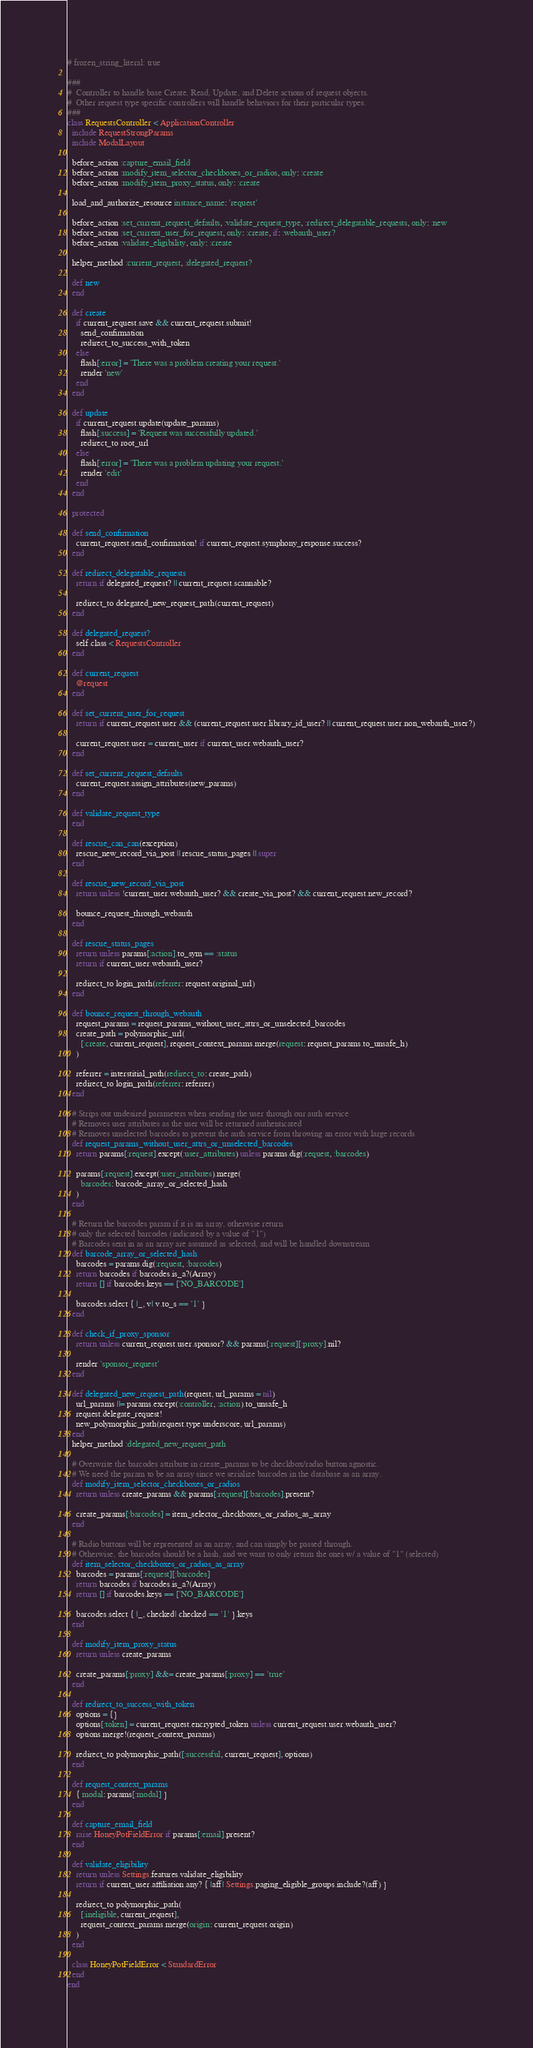<code> <loc_0><loc_0><loc_500><loc_500><_Ruby_># frozen_string_literal: true

###
#  Controller to handle base Create, Read, Update, and Delete actions of request objects.
#  Other request type specific controllers will handle behaviors for their particular types.
###
class RequestsController < ApplicationController
  include RequestStrongParams
  include ModalLayout

  before_action :capture_email_field
  before_action :modify_item_selector_checkboxes_or_radios, only: :create
  before_action :modify_item_proxy_status, only: :create

  load_and_authorize_resource instance_name: 'request'

  before_action :set_current_request_defaults, :validate_request_type, :redirect_delegatable_requests, only: :new
  before_action :set_current_user_for_request, only: :create, if: :webauth_user?
  before_action :validate_eligibility, only: :create

  helper_method :current_request, :delegated_request?

  def new
  end

  def create
    if current_request.save && current_request.submit!
      send_confirmation
      redirect_to_success_with_token
    else
      flash[:error] = 'There was a problem creating your request.'
      render 'new'
    end
  end

  def update
    if current_request.update(update_params)
      flash[:success] = 'Request was successfully updated.'
      redirect_to root_url
    else
      flash[:error] = 'There was a problem updating your request.'
      render 'edit'
    end
  end

  protected

  def send_confirmation
    current_request.send_confirmation! if current_request.symphony_response.success?
  end

  def redirect_delegatable_requests
    return if delegated_request? || current_request.scannable?

    redirect_to delegated_new_request_path(current_request)
  end

  def delegated_request?
    self.class < RequestsController
  end

  def current_request
    @request
  end

  def set_current_user_for_request
    return if current_request.user && (current_request.user.library_id_user? || current_request.user.non_webauth_user?)

    current_request.user = current_user if current_user.webauth_user?
  end

  def set_current_request_defaults
    current_request.assign_attributes(new_params)
  end

  def validate_request_type
  end

  def rescue_can_can(exception)
    rescue_new_record_via_post || rescue_status_pages || super
  end

  def rescue_new_record_via_post
    return unless !current_user.webauth_user? && create_via_post? && current_request.new_record?

    bounce_request_through_webauth
  end

  def rescue_status_pages
    return unless params[:action].to_sym == :status
    return if current_user.webauth_user?

    redirect_to login_path(referrer: request.original_url)
  end

  def bounce_request_through_webauth
    request_params = request_params_without_user_attrs_or_unselected_barcodes
    create_path = polymorphic_url(
      [:create, current_request], request_context_params.merge(request: request_params.to_unsafe_h)
    )

    referrer = interstitial_path(redirect_to: create_path)
    redirect_to login_path(referrer: referrer)
  end

  # Strips out undesired parameters when sending the user through our auth service
  # Removes user attributes as the user will be returned authenticated
  # Removes unselected barcodes to prevent the auth service from throwing an error with large records
  def request_params_without_user_attrs_or_unselected_barcodes
    return params[:request].except(:user_attributes) unless params.dig(:request, :barcodes)

    params[:request].except(:user_attributes).merge(
      barcodes: barcode_array_or_selected_hash
    )
  end

  # Return the barcodes param if it is an array, otherwise return
  # only the selected barcodes (indicated by a value of "1")
  # Barcodes sent in as an array are assumed as selected, and will be handled downstream
  def barcode_array_or_selected_hash
    barcodes = params.dig(:request, :barcodes)
    return barcodes if barcodes.is_a?(Array)
    return [] if barcodes.keys == ['NO_BARCODE']

    barcodes.select { |_, v| v.to_s == '1' }
  end

  def check_if_proxy_sponsor
    return unless current_request.user.sponsor? && params[:request][:proxy].nil?

    render 'sponsor_request'
  end

  def delegated_new_request_path(request, url_params = nil)
    url_params ||= params.except(:controller, :action).to_unsafe_h
    request.delegate_request!
    new_polymorphic_path(request.type.underscore, url_params)
  end
  helper_method :delegated_new_request_path

  # Overwrite the barcodes attribute in create_params to be checkbox/radio button agnostic.
  # We need the param to be an array since we serialize barcodes in the database as an array.
  def modify_item_selector_checkboxes_or_radios
    return unless create_params && params[:request][:barcodes].present?

    create_params[:barcodes] = item_selector_checkboxes_or_radios_as_array
  end

  # Radio buttons will be represented as an array, and can simply be passed through.
  # Otherwise, the barcodes should be a hash, and we want to only return the ones w/ a value of "1" (selected)
  def item_selector_checkboxes_or_radios_as_array
    barcodes = params[:request][:barcodes]
    return barcodes if barcodes.is_a?(Array)
    return [] if barcodes.keys == ['NO_BARCODE']

    barcodes.select { |_, checked| checked == '1' }.keys
  end

  def modify_item_proxy_status
    return unless create_params

    create_params[:proxy] &&= create_params[:proxy] == 'true'
  end

  def redirect_to_success_with_token
    options = {}
    options[:token] = current_request.encrypted_token unless current_request.user.webauth_user?
    options.merge!(request_context_params)

    redirect_to polymorphic_path([:successful, current_request], options)
  end

  def request_context_params
    { modal: params[:modal] }
  end

  def capture_email_field
    raise HoneyPotFieldError if params[:email].present?
  end

  def validate_eligibility
    return unless Settings.features.validate_eligibility
    return if current_user.affiliation.any? { |aff| Settings.paging_eligible_groups.include?(aff) }

    redirect_to polymorphic_path(
      [:ineligible, current_request],
      request_context_params.merge(origin: current_request.origin)
    )
  end

  class HoneyPotFieldError < StandardError
  end
end
</code> 